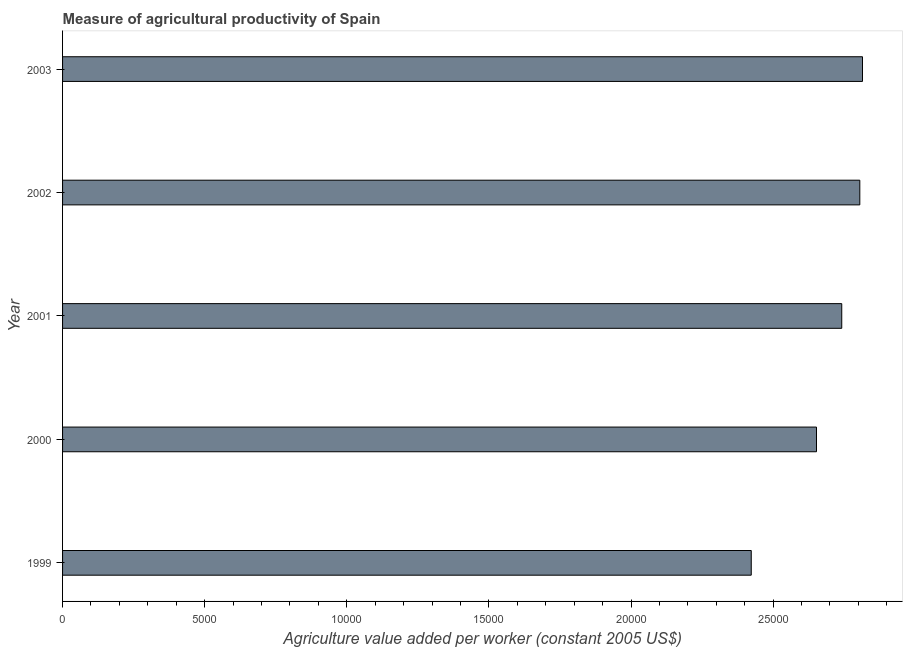Does the graph contain any zero values?
Keep it short and to the point. No. Does the graph contain grids?
Your answer should be compact. No. What is the title of the graph?
Your response must be concise. Measure of agricultural productivity of Spain. What is the label or title of the X-axis?
Your answer should be compact. Agriculture value added per worker (constant 2005 US$). What is the label or title of the Y-axis?
Your answer should be compact. Year. What is the agriculture value added per worker in 2002?
Ensure brevity in your answer.  2.81e+04. Across all years, what is the maximum agriculture value added per worker?
Your answer should be very brief. 2.81e+04. Across all years, what is the minimum agriculture value added per worker?
Offer a terse response. 2.42e+04. In which year was the agriculture value added per worker minimum?
Offer a terse response. 1999. What is the sum of the agriculture value added per worker?
Offer a terse response. 1.34e+05. What is the difference between the agriculture value added per worker in 2001 and 2003?
Provide a short and direct response. -730.18. What is the average agriculture value added per worker per year?
Offer a terse response. 2.69e+04. What is the median agriculture value added per worker?
Provide a succinct answer. 2.74e+04. Do a majority of the years between 2002 and 1999 (inclusive) have agriculture value added per worker greater than 24000 US$?
Offer a terse response. Yes. What is the ratio of the agriculture value added per worker in 2000 to that in 2001?
Provide a succinct answer. 0.97. Is the agriculture value added per worker in 2002 less than that in 2003?
Provide a short and direct response. Yes. What is the difference between the highest and the second highest agriculture value added per worker?
Provide a succinct answer. 94.16. What is the difference between the highest and the lowest agriculture value added per worker?
Your answer should be very brief. 3914.02. How many bars are there?
Your response must be concise. 5. How many years are there in the graph?
Provide a succinct answer. 5. What is the difference between two consecutive major ticks on the X-axis?
Ensure brevity in your answer.  5000. Are the values on the major ticks of X-axis written in scientific E-notation?
Give a very brief answer. No. What is the Agriculture value added per worker (constant 2005 US$) of 1999?
Keep it short and to the point. 2.42e+04. What is the Agriculture value added per worker (constant 2005 US$) in 2000?
Your answer should be compact. 2.65e+04. What is the Agriculture value added per worker (constant 2005 US$) in 2001?
Your answer should be very brief. 2.74e+04. What is the Agriculture value added per worker (constant 2005 US$) in 2002?
Provide a succinct answer. 2.81e+04. What is the Agriculture value added per worker (constant 2005 US$) in 2003?
Offer a terse response. 2.81e+04. What is the difference between the Agriculture value added per worker (constant 2005 US$) in 1999 and 2000?
Offer a terse response. -2295.49. What is the difference between the Agriculture value added per worker (constant 2005 US$) in 1999 and 2001?
Make the answer very short. -3183.84. What is the difference between the Agriculture value added per worker (constant 2005 US$) in 1999 and 2002?
Offer a very short reply. -3819.85. What is the difference between the Agriculture value added per worker (constant 2005 US$) in 1999 and 2003?
Provide a short and direct response. -3914.02. What is the difference between the Agriculture value added per worker (constant 2005 US$) in 2000 and 2001?
Your answer should be compact. -888.35. What is the difference between the Agriculture value added per worker (constant 2005 US$) in 2000 and 2002?
Provide a succinct answer. -1524.36. What is the difference between the Agriculture value added per worker (constant 2005 US$) in 2000 and 2003?
Provide a short and direct response. -1618.52. What is the difference between the Agriculture value added per worker (constant 2005 US$) in 2001 and 2002?
Give a very brief answer. -636.01. What is the difference between the Agriculture value added per worker (constant 2005 US$) in 2001 and 2003?
Your answer should be compact. -730.18. What is the difference between the Agriculture value added per worker (constant 2005 US$) in 2002 and 2003?
Your response must be concise. -94.16. What is the ratio of the Agriculture value added per worker (constant 2005 US$) in 1999 to that in 2000?
Your answer should be very brief. 0.91. What is the ratio of the Agriculture value added per worker (constant 2005 US$) in 1999 to that in 2001?
Provide a succinct answer. 0.88. What is the ratio of the Agriculture value added per worker (constant 2005 US$) in 1999 to that in 2002?
Give a very brief answer. 0.86. What is the ratio of the Agriculture value added per worker (constant 2005 US$) in 1999 to that in 2003?
Ensure brevity in your answer.  0.86. What is the ratio of the Agriculture value added per worker (constant 2005 US$) in 2000 to that in 2001?
Offer a very short reply. 0.97. What is the ratio of the Agriculture value added per worker (constant 2005 US$) in 2000 to that in 2002?
Your answer should be very brief. 0.95. What is the ratio of the Agriculture value added per worker (constant 2005 US$) in 2000 to that in 2003?
Give a very brief answer. 0.94. 